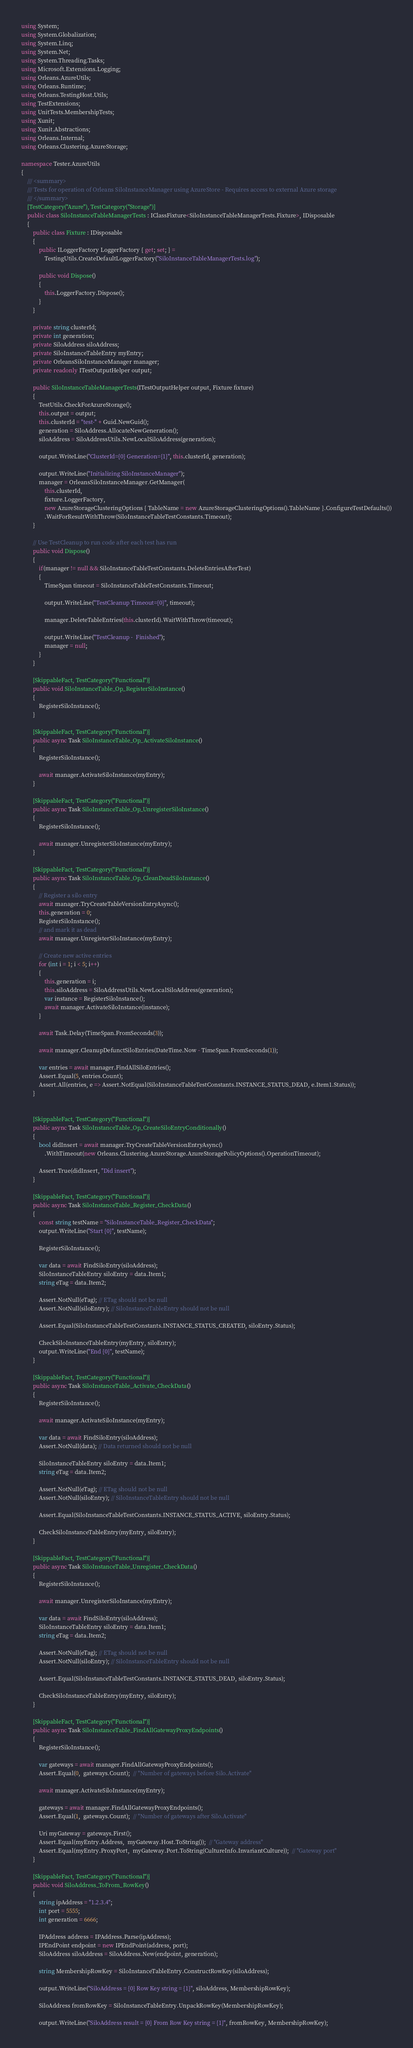Convert code to text. <code><loc_0><loc_0><loc_500><loc_500><_C#_>using System;
using System.Globalization;
using System.Linq;
using System.Net;
using System.Threading.Tasks;
using Microsoft.Extensions.Logging;
using Orleans.AzureUtils;
using Orleans.Runtime;
using Orleans.TestingHost.Utils;
using TestExtensions;
using UnitTests.MembershipTests;
using Xunit;
using Xunit.Abstractions;
using Orleans.Internal;
using Orleans.Clustering.AzureStorage;

namespace Tester.AzureUtils
{
    /// <summary>
    /// Tests for operation of Orleans SiloInstanceManager using AzureStore - Requires access to external Azure storage
    /// </summary>
    [TestCategory("Azure"), TestCategory("Storage")]
    public class SiloInstanceTableManagerTests : IClassFixture<SiloInstanceTableManagerTests.Fixture>, IDisposable
    {
        public class Fixture : IDisposable
        {
            public ILoggerFactory LoggerFactory { get; set; } =
                TestingUtils.CreateDefaultLoggerFactory("SiloInstanceTableManagerTests.log");

            public void Dispose()
            {
                this.LoggerFactory.Dispose();
            }
        }

        private string clusterId;
        private int generation;
        private SiloAddress siloAddress;
        private SiloInstanceTableEntry myEntry;
        private OrleansSiloInstanceManager manager;
        private readonly ITestOutputHelper output;

        public SiloInstanceTableManagerTests(ITestOutputHelper output, Fixture fixture)
        {
            TestUtils.CheckForAzureStorage();
            this.output = output;
            this.clusterId = "test-" + Guid.NewGuid();
            generation = SiloAddress.AllocateNewGeneration();
            siloAddress = SiloAddressUtils.NewLocalSiloAddress(generation);

            output.WriteLine("ClusterId={0} Generation={1}", this.clusterId, generation);

            output.WriteLine("Initializing SiloInstanceManager");
            manager = OrleansSiloInstanceManager.GetManager(
                this.clusterId,
                fixture.LoggerFactory,
                new AzureStorageClusteringOptions { TableName = new AzureStorageClusteringOptions().TableName }.ConfigureTestDefaults())
                .WaitForResultWithThrow(SiloInstanceTableTestConstants.Timeout);
        }

        // Use TestCleanup to run code after each test has run
        public void Dispose()
        {
            if(manager != null && SiloInstanceTableTestConstants.DeleteEntriesAfterTest)
            {
                TimeSpan timeout = SiloInstanceTableTestConstants.Timeout;

                output.WriteLine("TestCleanup Timeout={0}", timeout);

                manager.DeleteTableEntries(this.clusterId).WaitWithThrow(timeout);

                output.WriteLine("TestCleanup -  Finished");
                manager = null;
            }
        }

        [SkippableFact, TestCategory("Functional")]
        public void SiloInstanceTable_Op_RegisterSiloInstance()
        {
            RegisterSiloInstance();
        }

        [SkippableFact, TestCategory("Functional")]
        public async Task SiloInstanceTable_Op_ActivateSiloInstance()
        {
            RegisterSiloInstance();

            await manager.ActivateSiloInstance(myEntry);
        }

        [SkippableFact, TestCategory("Functional")]
        public async Task SiloInstanceTable_Op_UnregisterSiloInstance()
        {
            RegisterSiloInstance();

            await manager.UnregisterSiloInstance(myEntry);
        }

        [SkippableFact, TestCategory("Functional")]
        public async Task SiloInstanceTable_Op_CleanDeadSiloInstance()
        {
            // Register a silo entry
            await manager.TryCreateTableVersionEntryAsync();
            this.generation = 0;
            RegisterSiloInstance();
            // and mark it as dead
            await manager.UnregisterSiloInstance(myEntry);

            // Create new active entries
            for (int i = 1; i < 5; i++)
            {
                this.generation = i;
                this.siloAddress = SiloAddressUtils.NewLocalSiloAddress(generation);
                var instance = RegisterSiloInstance();
                await manager.ActivateSiloInstance(instance);
            }

            await Task.Delay(TimeSpan.FromSeconds(3));

            await manager.CleanupDefunctSiloEntries(DateTime.Now - TimeSpan.FromSeconds(1));

            var entries = await manager.FindAllSiloEntries();
            Assert.Equal(5, entries.Count);
            Assert.All(entries, e => Assert.NotEqual(SiloInstanceTableTestConstants.INSTANCE_STATUS_DEAD, e.Item1.Status));
        }


        [SkippableFact, TestCategory("Functional")]
        public async Task SiloInstanceTable_Op_CreateSiloEntryConditionally()
        {
            bool didInsert = await manager.TryCreateTableVersionEntryAsync()
                .WithTimeout(new Orleans.Clustering.AzureStorage.AzureStoragePolicyOptions().OperationTimeout);

            Assert.True(didInsert, "Did insert");
        }

        [SkippableFact, TestCategory("Functional")]
        public async Task SiloInstanceTable_Register_CheckData()
        {
            const string testName = "SiloInstanceTable_Register_CheckData";
            output.WriteLine("Start {0}", testName);

            RegisterSiloInstance();

            var data = await FindSiloEntry(siloAddress);
            SiloInstanceTableEntry siloEntry = data.Item1;
            string eTag = data.Item2;

            Assert.NotNull(eTag); // ETag should not be null
            Assert.NotNull(siloEntry); // SiloInstanceTableEntry should not be null

            Assert.Equal(SiloInstanceTableTestConstants.INSTANCE_STATUS_CREATED, siloEntry.Status);

            CheckSiloInstanceTableEntry(myEntry, siloEntry);
            output.WriteLine("End {0}", testName);
        }

        [SkippableFact, TestCategory("Functional")]
        public async Task SiloInstanceTable_Activate_CheckData()
        {
            RegisterSiloInstance();

            await manager.ActivateSiloInstance(myEntry);

            var data = await FindSiloEntry(siloAddress);
            Assert.NotNull(data); // Data returned should not be null

            SiloInstanceTableEntry siloEntry = data.Item1;
            string eTag = data.Item2;

            Assert.NotNull(eTag); // ETag should not be null
            Assert.NotNull(siloEntry); // SiloInstanceTableEntry should not be null

            Assert.Equal(SiloInstanceTableTestConstants.INSTANCE_STATUS_ACTIVE, siloEntry.Status);

            CheckSiloInstanceTableEntry(myEntry, siloEntry);
        }

        [SkippableFact, TestCategory("Functional")]
        public async Task SiloInstanceTable_Unregister_CheckData()
        {
            RegisterSiloInstance();

            await manager.UnregisterSiloInstance(myEntry);

            var data = await FindSiloEntry(siloAddress);
            SiloInstanceTableEntry siloEntry = data.Item1;
            string eTag = data.Item2;

            Assert.NotNull(eTag); // ETag should not be null
            Assert.NotNull(siloEntry); // SiloInstanceTableEntry should not be null

            Assert.Equal(SiloInstanceTableTestConstants.INSTANCE_STATUS_DEAD, siloEntry.Status);

            CheckSiloInstanceTableEntry(myEntry, siloEntry);
        }

        [SkippableFact, TestCategory("Functional")]
        public async Task SiloInstanceTable_FindAllGatewayProxyEndpoints()
        {
            RegisterSiloInstance();

            var gateways = await manager.FindAllGatewayProxyEndpoints();
            Assert.Equal(0,  gateways.Count);  // "Number of gateways before Silo.Activate"

            await manager.ActivateSiloInstance(myEntry);

            gateways = await manager.FindAllGatewayProxyEndpoints();
            Assert.Equal(1,  gateways.Count);  // "Number of gateways after Silo.Activate"

            Uri myGateway = gateways.First();
            Assert.Equal(myEntry.Address,  myGateway.Host.ToString());  // "Gateway address"
            Assert.Equal(myEntry.ProxyPort,  myGateway.Port.ToString(CultureInfo.InvariantCulture));  // "Gateway port"
        }

        [SkippableFact, TestCategory("Functional")]
        public void SiloAddress_ToFrom_RowKey()
        {
            string ipAddress = "1.2.3.4";
            int port = 5555;
            int generation = 6666;

            IPAddress address = IPAddress.Parse(ipAddress);
            IPEndPoint endpoint = new IPEndPoint(address, port);
            SiloAddress siloAddress = SiloAddress.New(endpoint, generation);

            string MembershipRowKey = SiloInstanceTableEntry.ConstructRowKey(siloAddress);

            output.WriteLine("SiloAddress = {0} Row Key string = {1}", siloAddress, MembershipRowKey);

            SiloAddress fromRowKey = SiloInstanceTableEntry.UnpackRowKey(MembershipRowKey);

            output.WriteLine("SiloAddress result = {0} From Row Key string = {1}", fromRowKey, MembershipRowKey);
</code> 